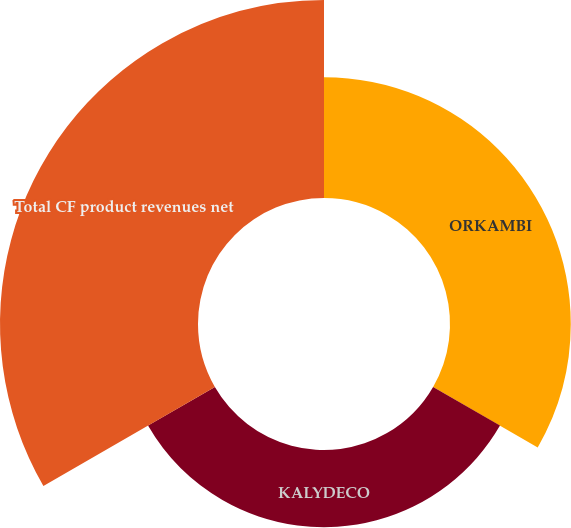<chart> <loc_0><loc_0><loc_500><loc_500><pie_chart><fcel>ORKAMBI<fcel>KALYDECO<fcel>Total CF product revenues net<nl><fcel>30.5%<fcel>19.5%<fcel>50.0%<nl></chart> 